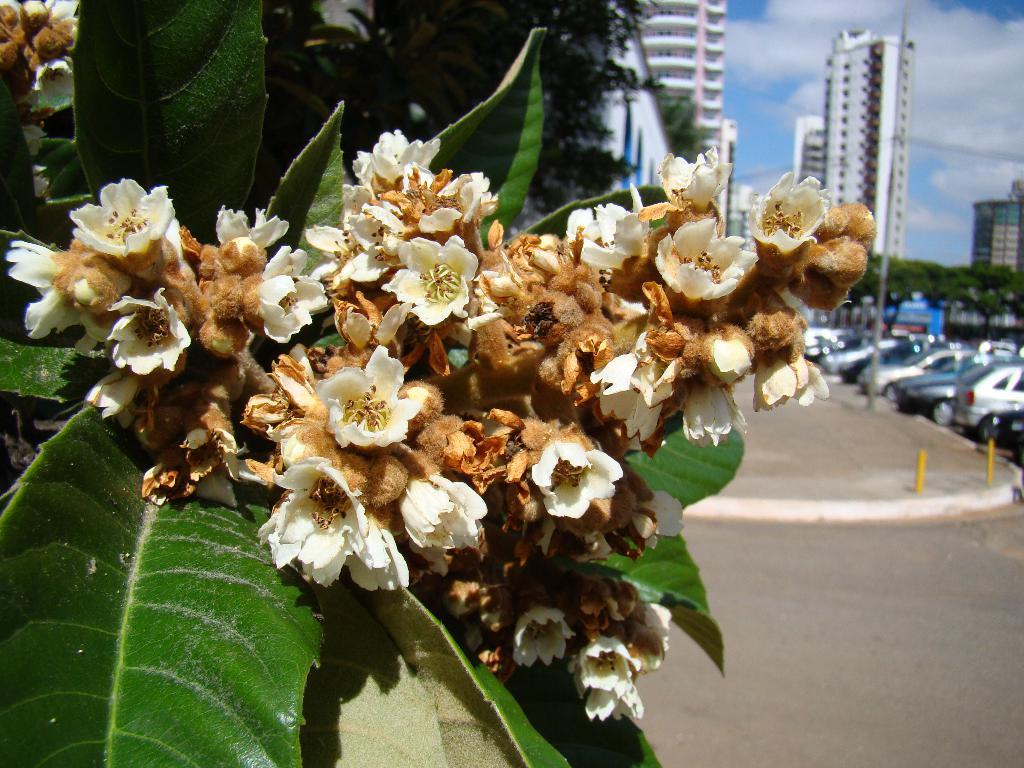What type of vegetation can be seen in the image? There are leaves and flowers in the image. What can be seen in the background of the image? There are trees, buildings, poles, and clouds in the sky in the background of the image. What is present on the right side of the image? There are vehicles on the road on the right side of the image. Can you describe the wire that is causing the earthquake in the image? There is no wire or earthquake present in the image. 